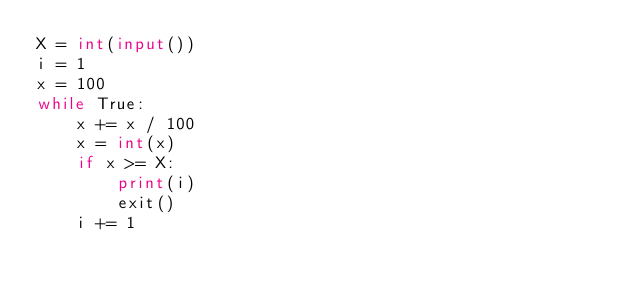<code> <loc_0><loc_0><loc_500><loc_500><_Python_>X = int(input())
i = 1
x = 100
while True:
    x += x / 100 
    x = int(x)
    if x >= X:
        print(i)
        exit()
    i += 1</code> 